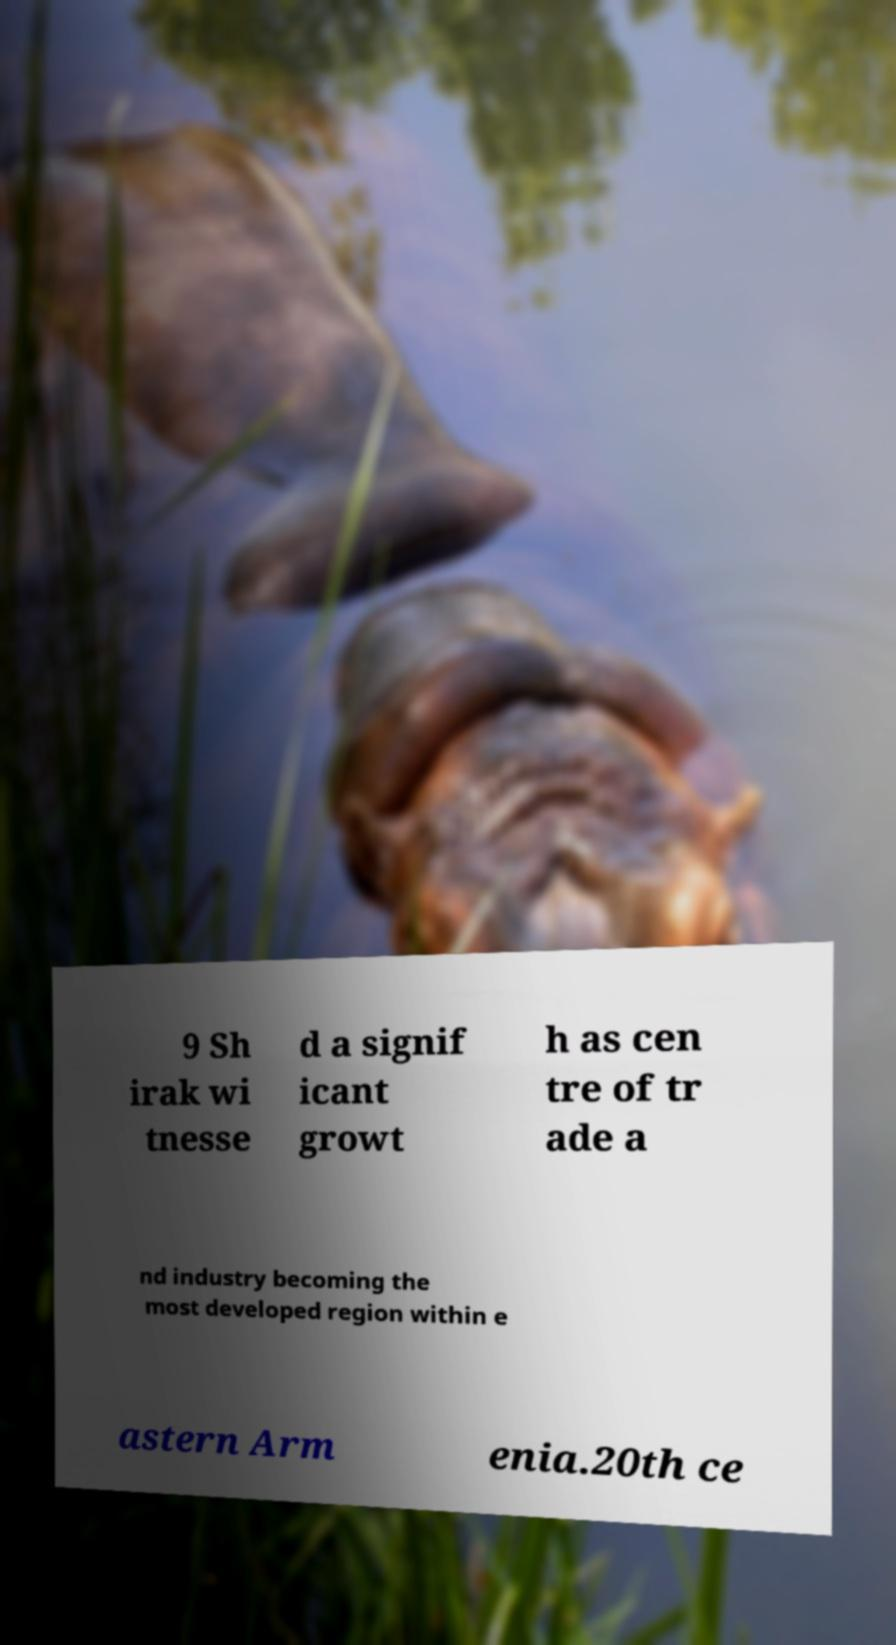For documentation purposes, I need the text within this image transcribed. Could you provide that? 9 Sh irak wi tnesse d a signif icant growt h as cen tre of tr ade a nd industry becoming the most developed region within e astern Arm enia.20th ce 